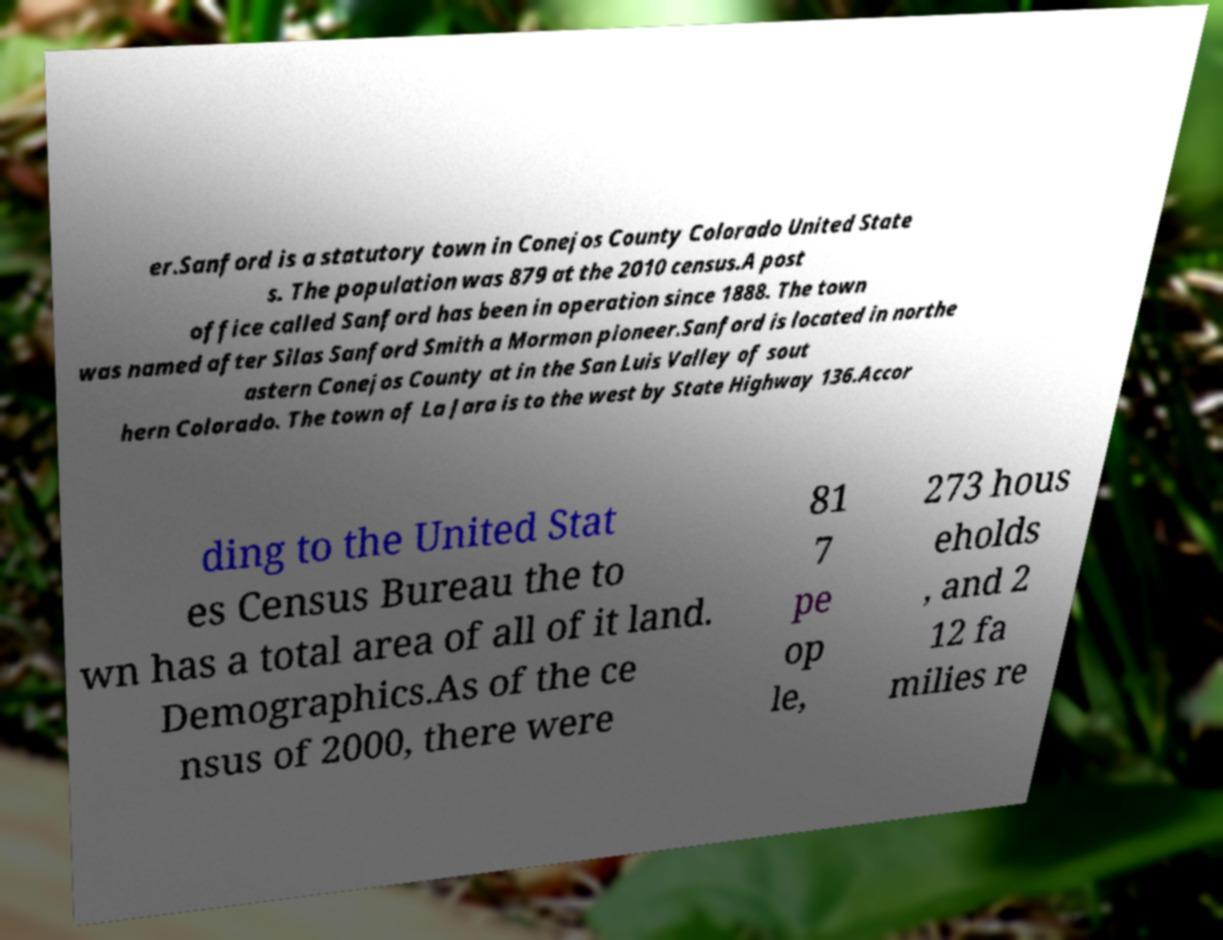Please identify and transcribe the text found in this image. er.Sanford is a statutory town in Conejos County Colorado United State s. The population was 879 at the 2010 census.A post office called Sanford has been in operation since 1888. The town was named after Silas Sanford Smith a Mormon pioneer.Sanford is located in northe astern Conejos County at in the San Luis Valley of sout hern Colorado. The town of La Jara is to the west by State Highway 136.Accor ding to the United Stat es Census Bureau the to wn has a total area of all of it land. Demographics.As of the ce nsus of 2000, there were 81 7 pe op le, 273 hous eholds , and 2 12 fa milies re 